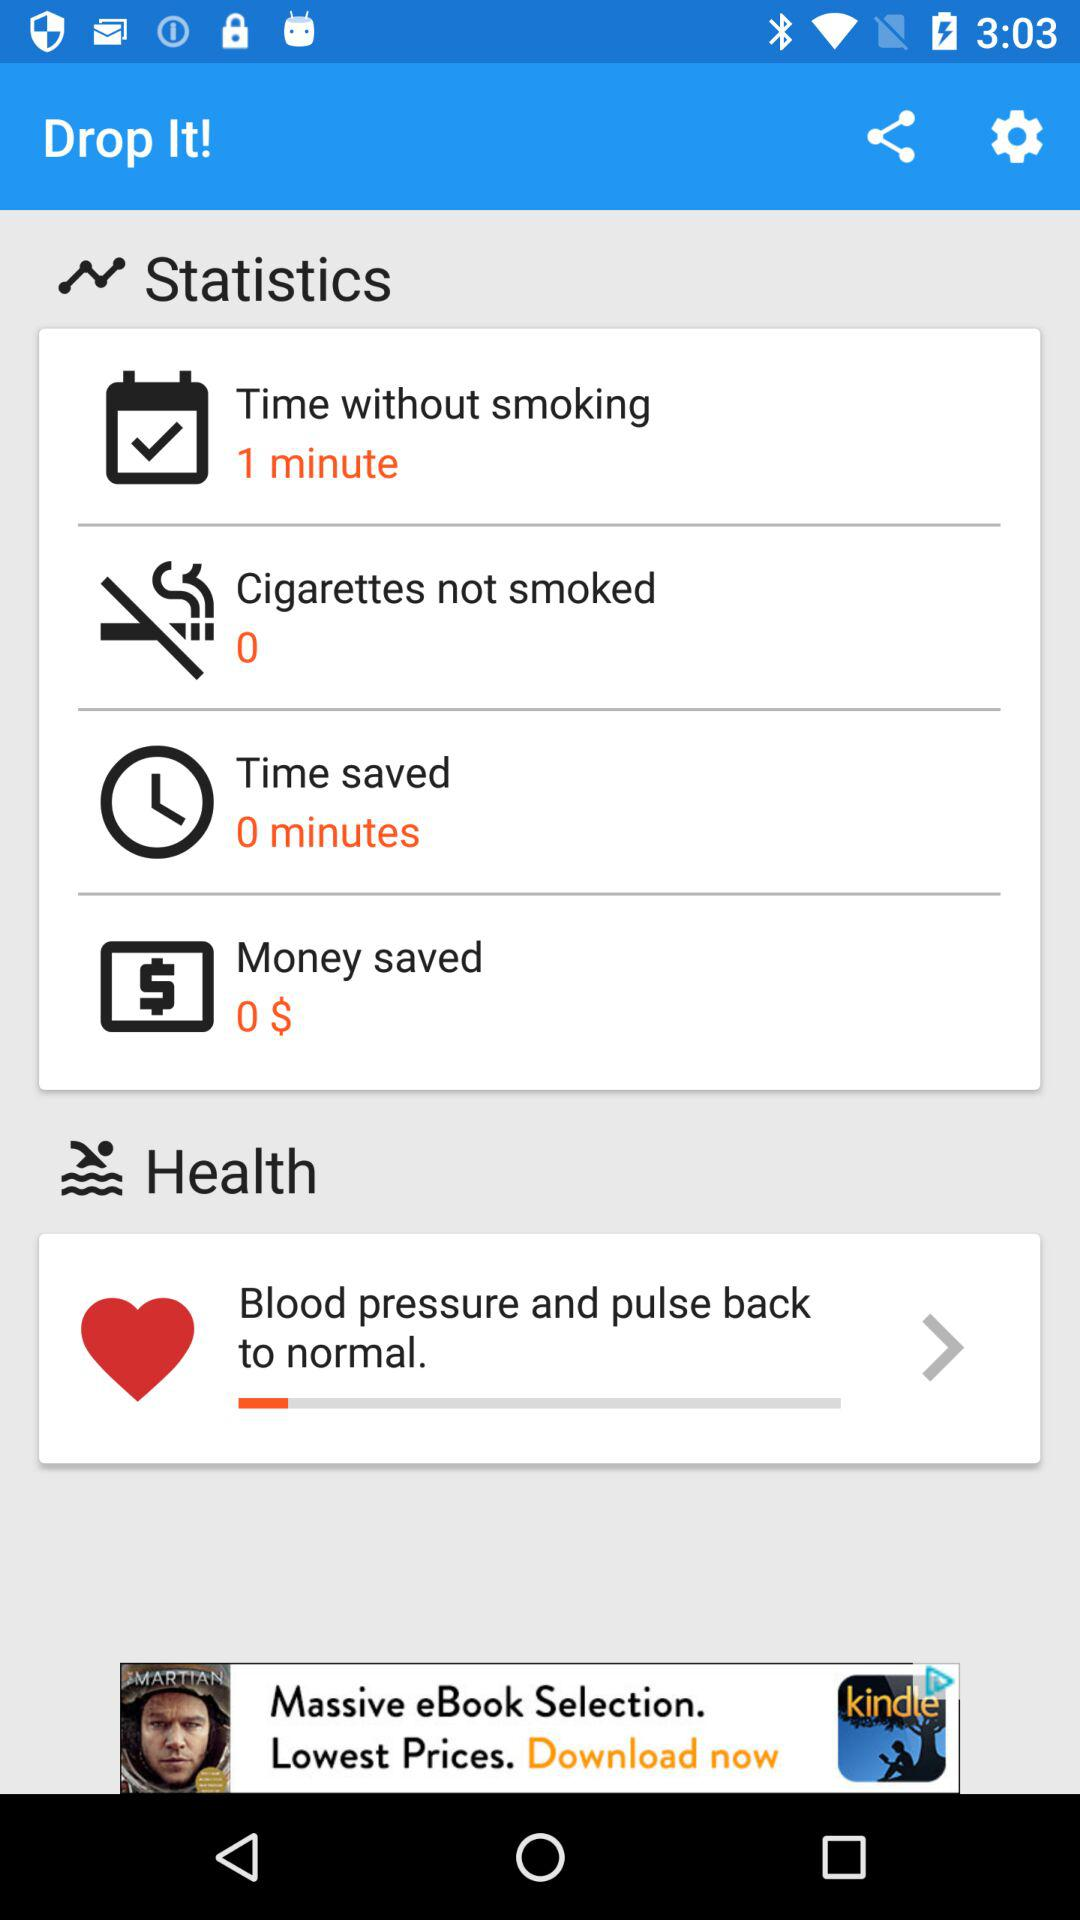How many cigarettes have not been smoked in total?
Answer the question using a single word or phrase. 0 